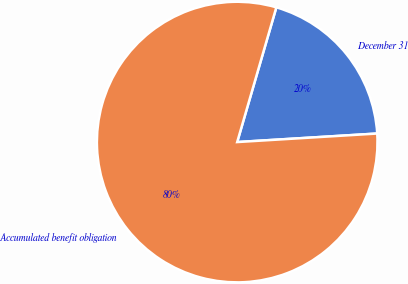Convert chart to OTSL. <chart><loc_0><loc_0><loc_500><loc_500><pie_chart><fcel>December 31<fcel>Accumulated benefit obligation<nl><fcel>19.53%<fcel>80.47%<nl></chart> 